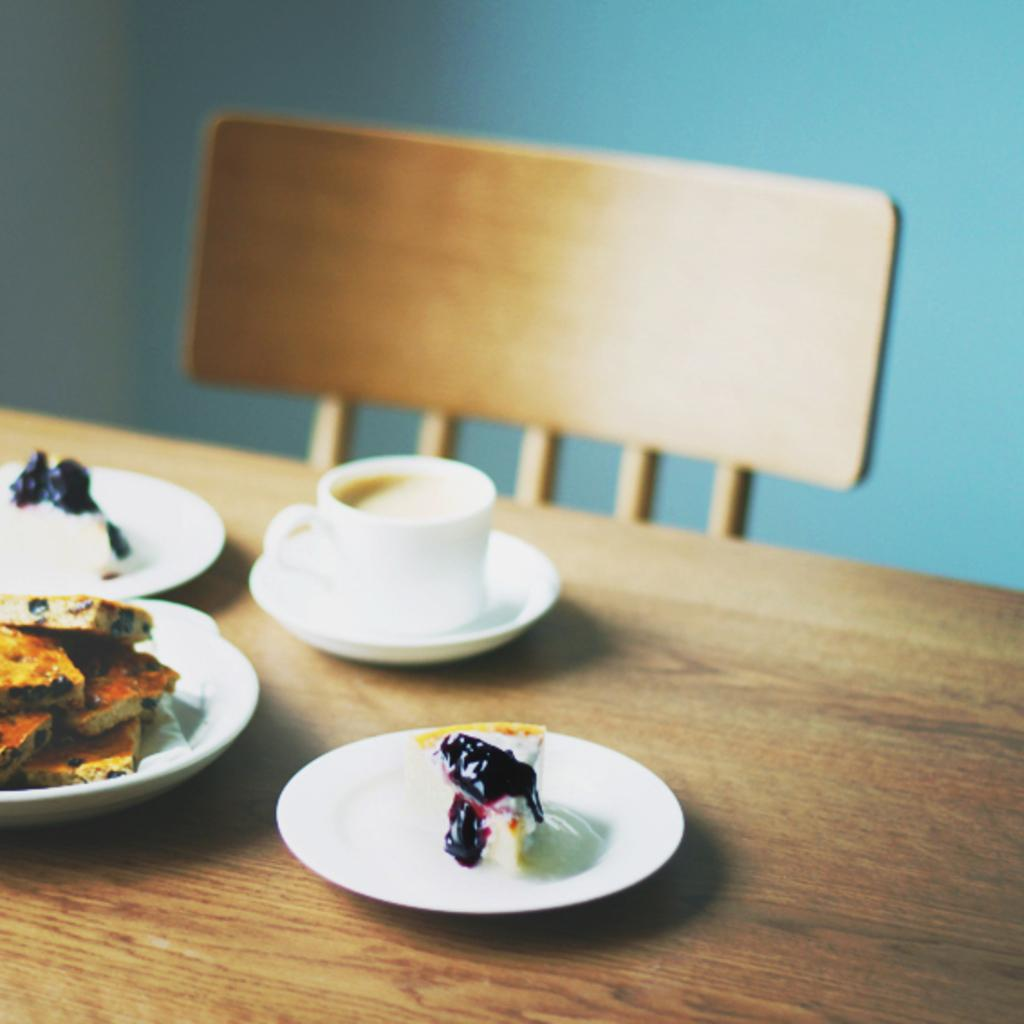What piece of furniture is present in the image? There is a table in the image. What is placed on the table? There is a plate, a cup, coffee, a saucer, biscuits, and a cake on the table. What is in the cup? There is coffee in the cup. What is the purpose of the saucer? The saucer is likely used to catch any spills or drips from the cup. What type of food is on the table? There are biscuits and a cake on the table. What can be seen in the background of the image? There is a wall and an empty chair in the background of the image. What type of drug is being served on the table in the image? There is no drug present in the image; it features a table with a plate, cup, coffee, saucer, biscuits, and a cake. 